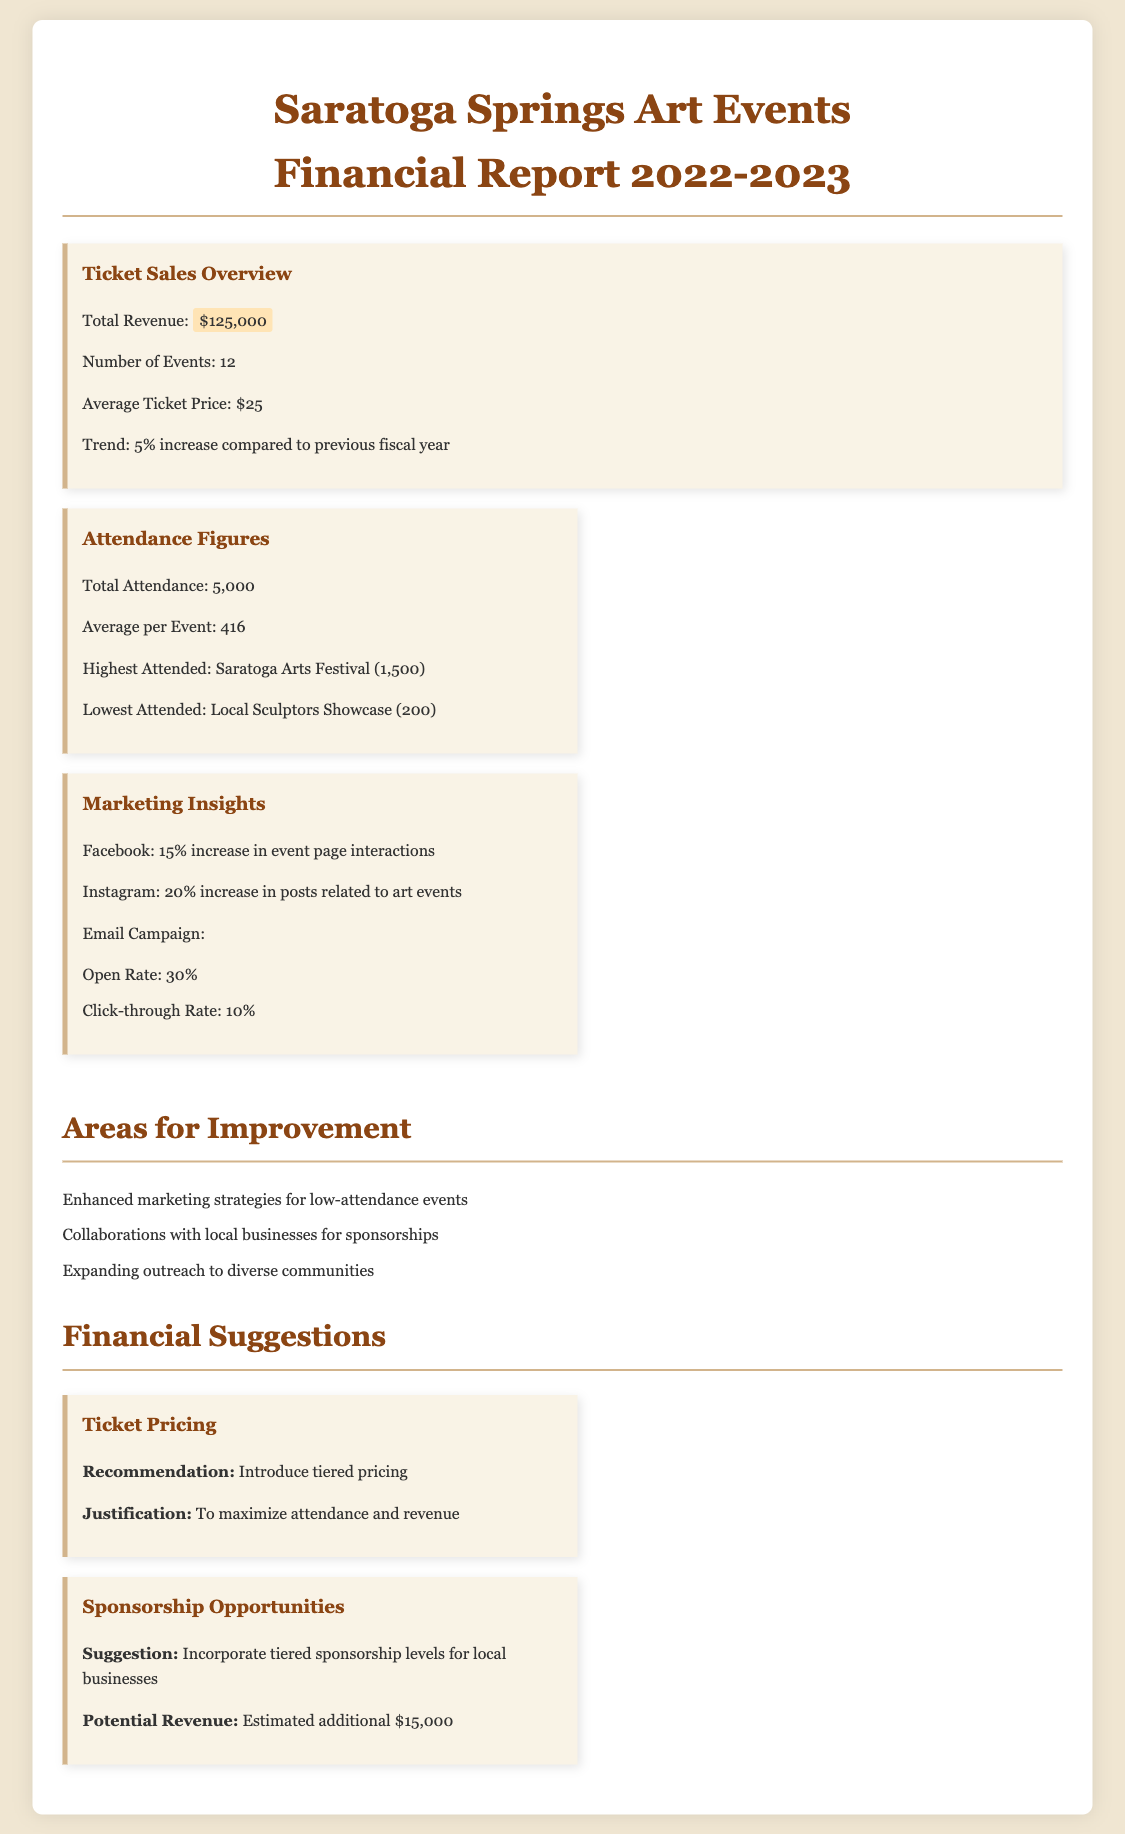What was the total revenue from ticket sales? The total revenue is stated in the document as $125,000.
Answer: $125,000 How many events were held in the fiscal year? The document specifies that there were 12 events.
Answer: 12 What was the highest attended event? The document indicates that the highest attended event was the Saratoga Arts Festival.
Answer: Saratoga Arts Festival What is the average ticket price? The average ticket price is mentioned as $25.
Answer: $25 What is the total attendance across all events? The total attendance is provided in the document as 5,000.
Answer: 5,000 What marketing platform had a 20% increase in engagement? The document states that Instagram had a 20% increase in posts related to art events.
Answer: Instagram What are two suggested areas for improvement? The document lists enhanced marketing strategies and collaborations with local businesses.
Answer: Enhanced marketing strategies and collaborations with local businesses What is the estimated additional revenue from tiered sponsorship levels? The document suggests that the estimated additional revenue could be $15,000.
Answer: $15,000 What was the attendance figure for the lowest attended event? The document states the lowest attended event had 200 attendees.
Answer: 200 